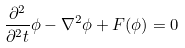Convert formula to latex. <formula><loc_0><loc_0><loc_500><loc_500>\frac { \partial ^ { 2 } } { \partial ^ { 2 } t } \phi - \nabla ^ { 2 } \phi + F ( \phi ) = 0</formula> 